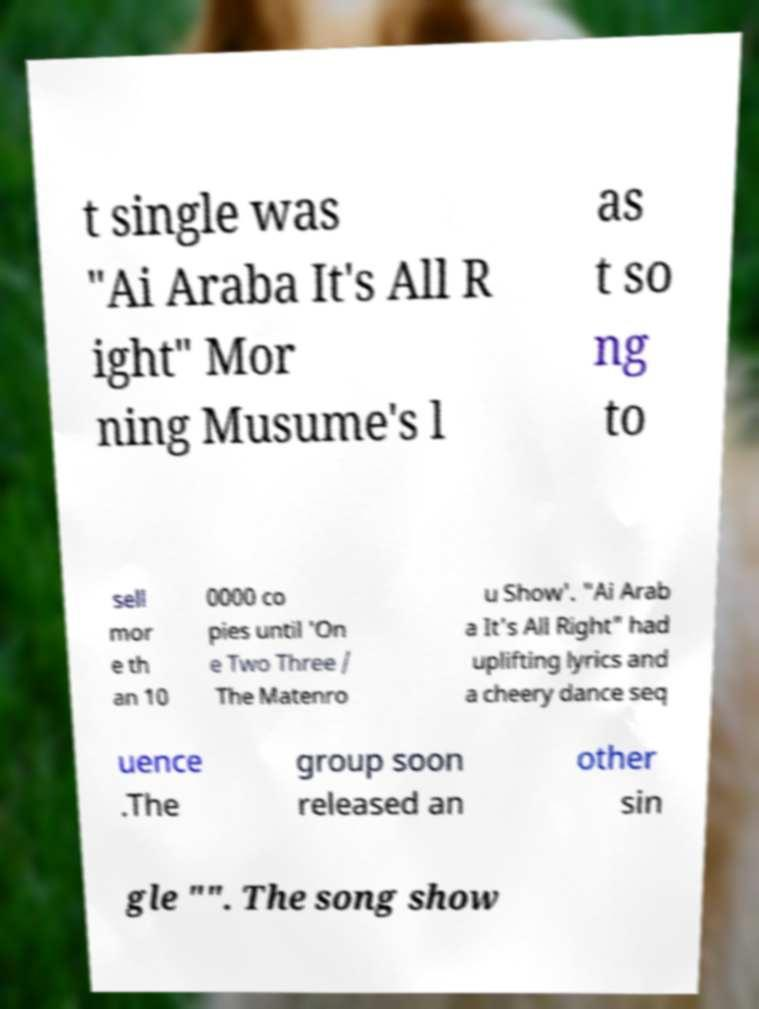There's text embedded in this image that I need extracted. Can you transcribe it verbatim? t single was "Ai Araba It's All R ight" Mor ning Musume's l as t so ng to sell mor e th an 10 0000 co pies until 'On e Two Three / The Matenro u Show'. "Ai Arab a It's All Right" had uplifting lyrics and a cheery dance seq uence .The group soon released an other sin gle "". The song show 